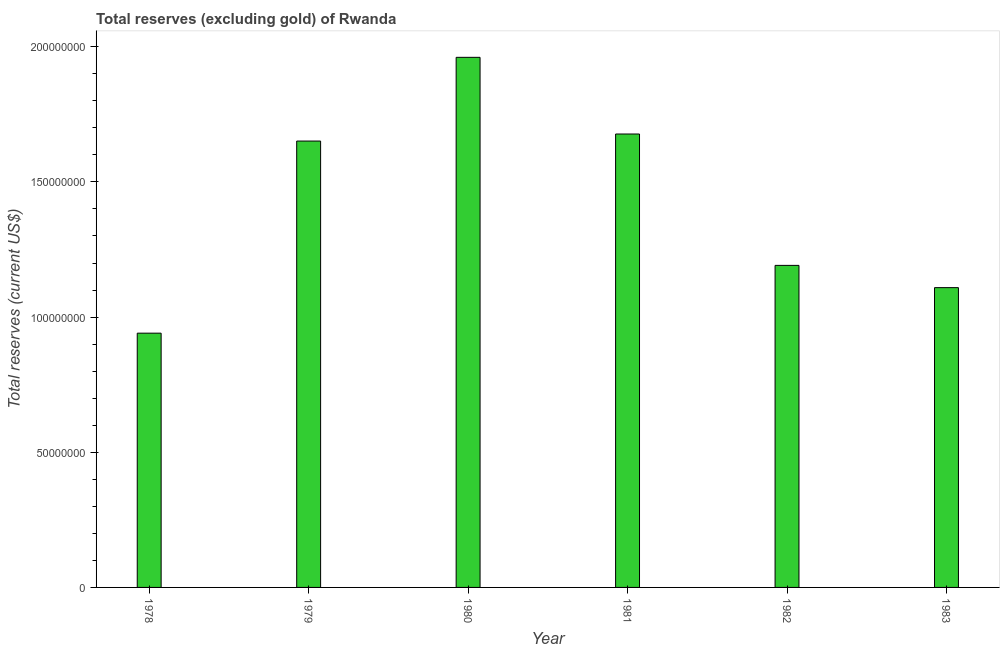Does the graph contain grids?
Ensure brevity in your answer.  No. What is the title of the graph?
Your response must be concise. Total reserves (excluding gold) of Rwanda. What is the label or title of the X-axis?
Offer a terse response. Year. What is the label or title of the Y-axis?
Give a very brief answer. Total reserves (current US$). What is the total reserves (excluding gold) in 1981?
Your answer should be compact. 1.68e+08. Across all years, what is the maximum total reserves (excluding gold)?
Your answer should be very brief. 1.96e+08. Across all years, what is the minimum total reserves (excluding gold)?
Give a very brief answer. 9.41e+07. In which year was the total reserves (excluding gold) minimum?
Make the answer very short. 1978. What is the sum of the total reserves (excluding gold)?
Your answer should be compact. 8.53e+08. What is the difference between the total reserves (excluding gold) in 1980 and 1983?
Give a very brief answer. 8.52e+07. What is the average total reserves (excluding gold) per year?
Offer a very short reply. 1.42e+08. What is the median total reserves (excluding gold)?
Provide a short and direct response. 1.42e+08. What is the ratio of the total reserves (excluding gold) in 1980 to that in 1981?
Ensure brevity in your answer.  1.17. What is the difference between the highest and the second highest total reserves (excluding gold)?
Provide a short and direct response. 2.84e+07. Is the sum of the total reserves (excluding gold) in 1979 and 1980 greater than the maximum total reserves (excluding gold) across all years?
Your answer should be compact. Yes. What is the difference between the highest and the lowest total reserves (excluding gold)?
Provide a short and direct response. 1.02e+08. In how many years, is the total reserves (excluding gold) greater than the average total reserves (excluding gold) taken over all years?
Make the answer very short. 3. How many bars are there?
Make the answer very short. 6. Are all the bars in the graph horizontal?
Your answer should be very brief. No. How many years are there in the graph?
Make the answer very short. 6. Are the values on the major ticks of Y-axis written in scientific E-notation?
Ensure brevity in your answer.  No. What is the Total reserves (current US$) of 1978?
Offer a very short reply. 9.41e+07. What is the Total reserves (current US$) of 1979?
Your answer should be compact. 1.65e+08. What is the Total reserves (current US$) in 1980?
Make the answer very short. 1.96e+08. What is the Total reserves (current US$) in 1981?
Make the answer very short. 1.68e+08. What is the Total reserves (current US$) of 1982?
Give a very brief answer. 1.19e+08. What is the Total reserves (current US$) of 1983?
Ensure brevity in your answer.  1.11e+08. What is the difference between the Total reserves (current US$) in 1978 and 1979?
Your answer should be very brief. -7.11e+07. What is the difference between the Total reserves (current US$) in 1978 and 1980?
Give a very brief answer. -1.02e+08. What is the difference between the Total reserves (current US$) in 1978 and 1981?
Give a very brief answer. -7.37e+07. What is the difference between the Total reserves (current US$) in 1978 and 1982?
Give a very brief answer. -2.51e+07. What is the difference between the Total reserves (current US$) in 1978 and 1983?
Provide a succinct answer. -1.68e+07. What is the difference between the Total reserves (current US$) in 1979 and 1980?
Provide a succinct answer. -3.10e+07. What is the difference between the Total reserves (current US$) in 1979 and 1981?
Ensure brevity in your answer.  -2.61e+06. What is the difference between the Total reserves (current US$) in 1979 and 1982?
Provide a short and direct response. 4.60e+07. What is the difference between the Total reserves (current US$) in 1979 and 1983?
Your answer should be very brief. 5.42e+07. What is the difference between the Total reserves (current US$) in 1980 and 1981?
Provide a short and direct response. 2.84e+07. What is the difference between the Total reserves (current US$) in 1980 and 1982?
Give a very brief answer. 7.70e+07. What is the difference between the Total reserves (current US$) in 1980 and 1983?
Offer a terse response. 8.52e+07. What is the difference between the Total reserves (current US$) in 1981 and 1982?
Your answer should be compact. 4.86e+07. What is the difference between the Total reserves (current US$) in 1981 and 1983?
Offer a very short reply. 5.68e+07. What is the difference between the Total reserves (current US$) in 1982 and 1983?
Provide a succinct answer. 8.23e+06. What is the ratio of the Total reserves (current US$) in 1978 to that in 1979?
Provide a succinct answer. 0.57. What is the ratio of the Total reserves (current US$) in 1978 to that in 1980?
Give a very brief answer. 0.48. What is the ratio of the Total reserves (current US$) in 1978 to that in 1981?
Ensure brevity in your answer.  0.56. What is the ratio of the Total reserves (current US$) in 1978 to that in 1982?
Make the answer very short. 0.79. What is the ratio of the Total reserves (current US$) in 1978 to that in 1983?
Offer a very short reply. 0.85. What is the ratio of the Total reserves (current US$) in 1979 to that in 1980?
Ensure brevity in your answer.  0.84. What is the ratio of the Total reserves (current US$) in 1979 to that in 1981?
Provide a short and direct response. 0.98. What is the ratio of the Total reserves (current US$) in 1979 to that in 1982?
Provide a short and direct response. 1.39. What is the ratio of the Total reserves (current US$) in 1979 to that in 1983?
Your answer should be compact. 1.49. What is the ratio of the Total reserves (current US$) in 1980 to that in 1981?
Provide a short and direct response. 1.17. What is the ratio of the Total reserves (current US$) in 1980 to that in 1982?
Offer a terse response. 1.65. What is the ratio of the Total reserves (current US$) in 1980 to that in 1983?
Offer a terse response. 1.77. What is the ratio of the Total reserves (current US$) in 1981 to that in 1982?
Offer a terse response. 1.41. What is the ratio of the Total reserves (current US$) in 1981 to that in 1983?
Give a very brief answer. 1.51. What is the ratio of the Total reserves (current US$) in 1982 to that in 1983?
Keep it short and to the point. 1.07. 